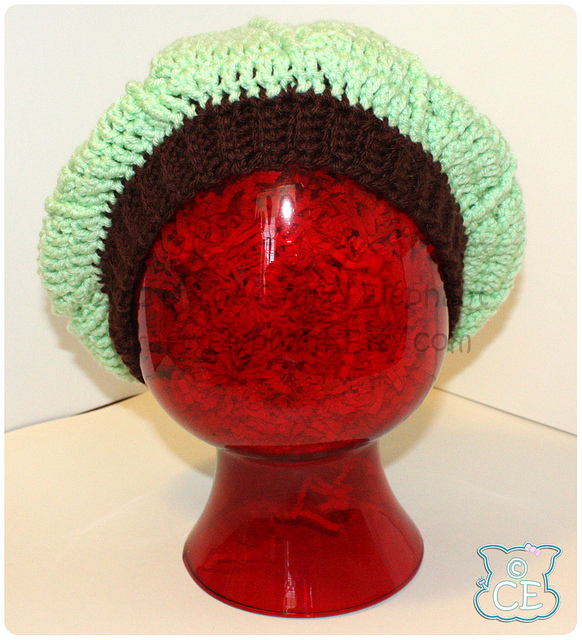Identify the text displayed in this image. CE 